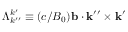Convert formula to latex. <formula><loc_0><loc_0><loc_500><loc_500>\Lambda _ { k ^ { \prime \prime } } ^ { k ^ { \prime } } \equiv ( c / B _ { 0 } ) b \cdot k ^ { \prime \prime } \times k ^ { \prime }</formula> 